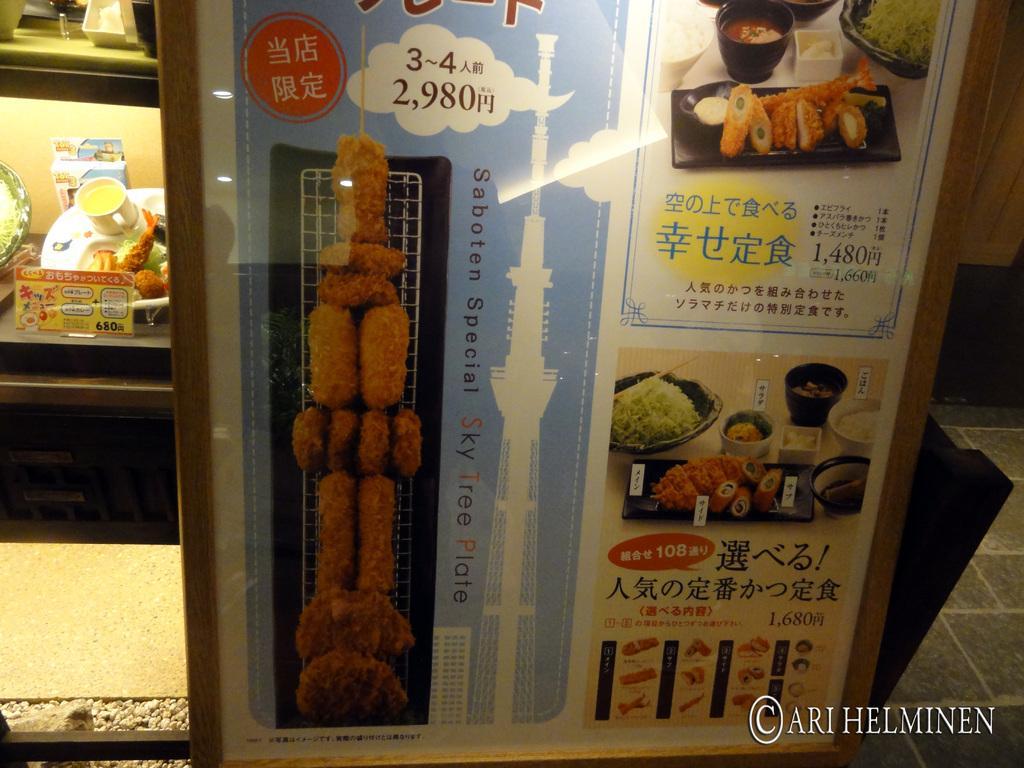Please provide a concise description of this image. In this picture we can see a poster on a surface, here we can see a grill, food items, bowls, some objects, some text and some numbers on it and in the background we can see a floor, plate, cup, wall and some objects. 